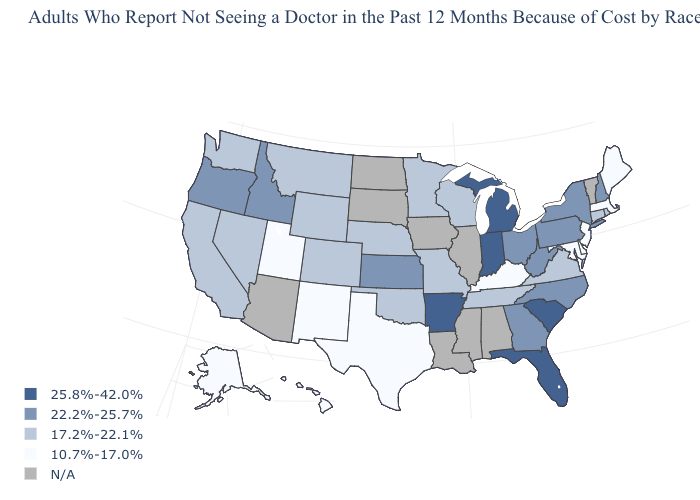What is the value of Rhode Island?
Quick response, please. 17.2%-22.1%. Name the states that have a value in the range 17.2%-22.1%?
Quick response, please. California, Colorado, Connecticut, Minnesota, Missouri, Montana, Nebraska, Nevada, Oklahoma, Rhode Island, Tennessee, Virginia, Washington, Wisconsin, Wyoming. Name the states that have a value in the range 10.7%-17.0%?
Be succinct. Alaska, Delaware, Hawaii, Kentucky, Maine, Maryland, Massachusetts, New Jersey, New Mexico, Texas, Utah. Name the states that have a value in the range 22.2%-25.7%?
Give a very brief answer. Georgia, Idaho, Kansas, New Hampshire, New York, North Carolina, Ohio, Oregon, Pennsylvania, West Virginia. Does California have the lowest value in the USA?
Write a very short answer. No. Does Oklahoma have the highest value in the South?
Concise answer only. No. Name the states that have a value in the range N/A?
Quick response, please. Alabama, Arizona, Illinois, Iowa, Louisiana, Mississippi, North Dakota, South Dakota, Vermont. Which states hav the highest value in the South?
Give a very brief answer. Arkansas, Florida, South Carolina. Does the first symbol in the legend represent the smallest category?
Be succinct. No. Among the states that border Virginia , which have the lowest value?
Quick response, please. Kentucky, Maryland. What is the value of Georgia?
Write a very short answer. 22.2%-25.7%. What is the highest value in the USA?
Write a very short answer. 25.8%-42.0%. What is the highest value in states that border Minnesota?
Quick response, please. 17.2%-22.1%. Name the states that have a value in the range 25.8%-42.0%?
Short answer required. Arkansas, Florida, Indiana, Michigan, South Carolina. What is the value of New Jersey?
Keep it brief. 10.7%-17.0%. 